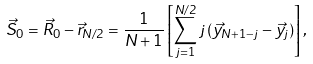<formula> <loc_0><loc_0><loc_500><loc_500>\vec { S } _ { 0 } = \vec { R } _ { 0 } - \vec { r } _ { N / 2 } = \frac { 1 } { N + 1 } \left [ \sum ^ { N / 2 } _ { j = 1 } j \, ( \vec { y } _ { N + 1 - j } - \vec { y } _ { j } ) \right ] ,</formula> 